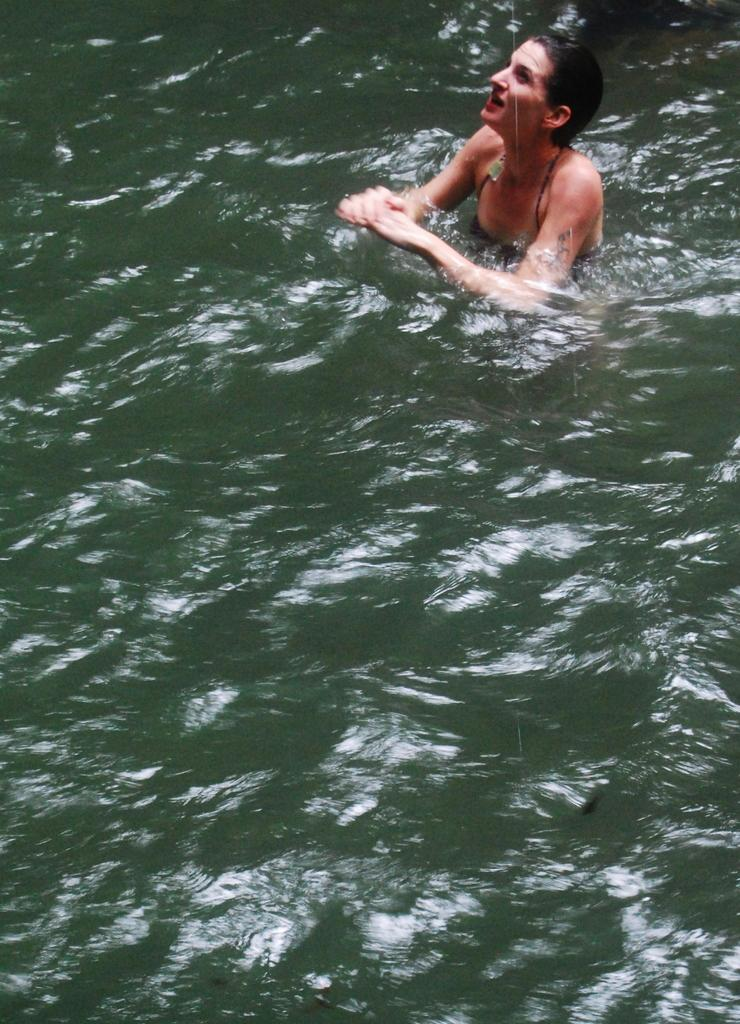Who or what is present in the image? There is a person in the image. Can you describe the person's location? The person is in the water. What color is the water in the image? The water is green in color. How many carts can be seen in the water with the person? There are no carts present in the image; it only features a person in the green water. Are there any bananas floating near the person? There are no bananas visible in the image; it only shows a person in the water. 